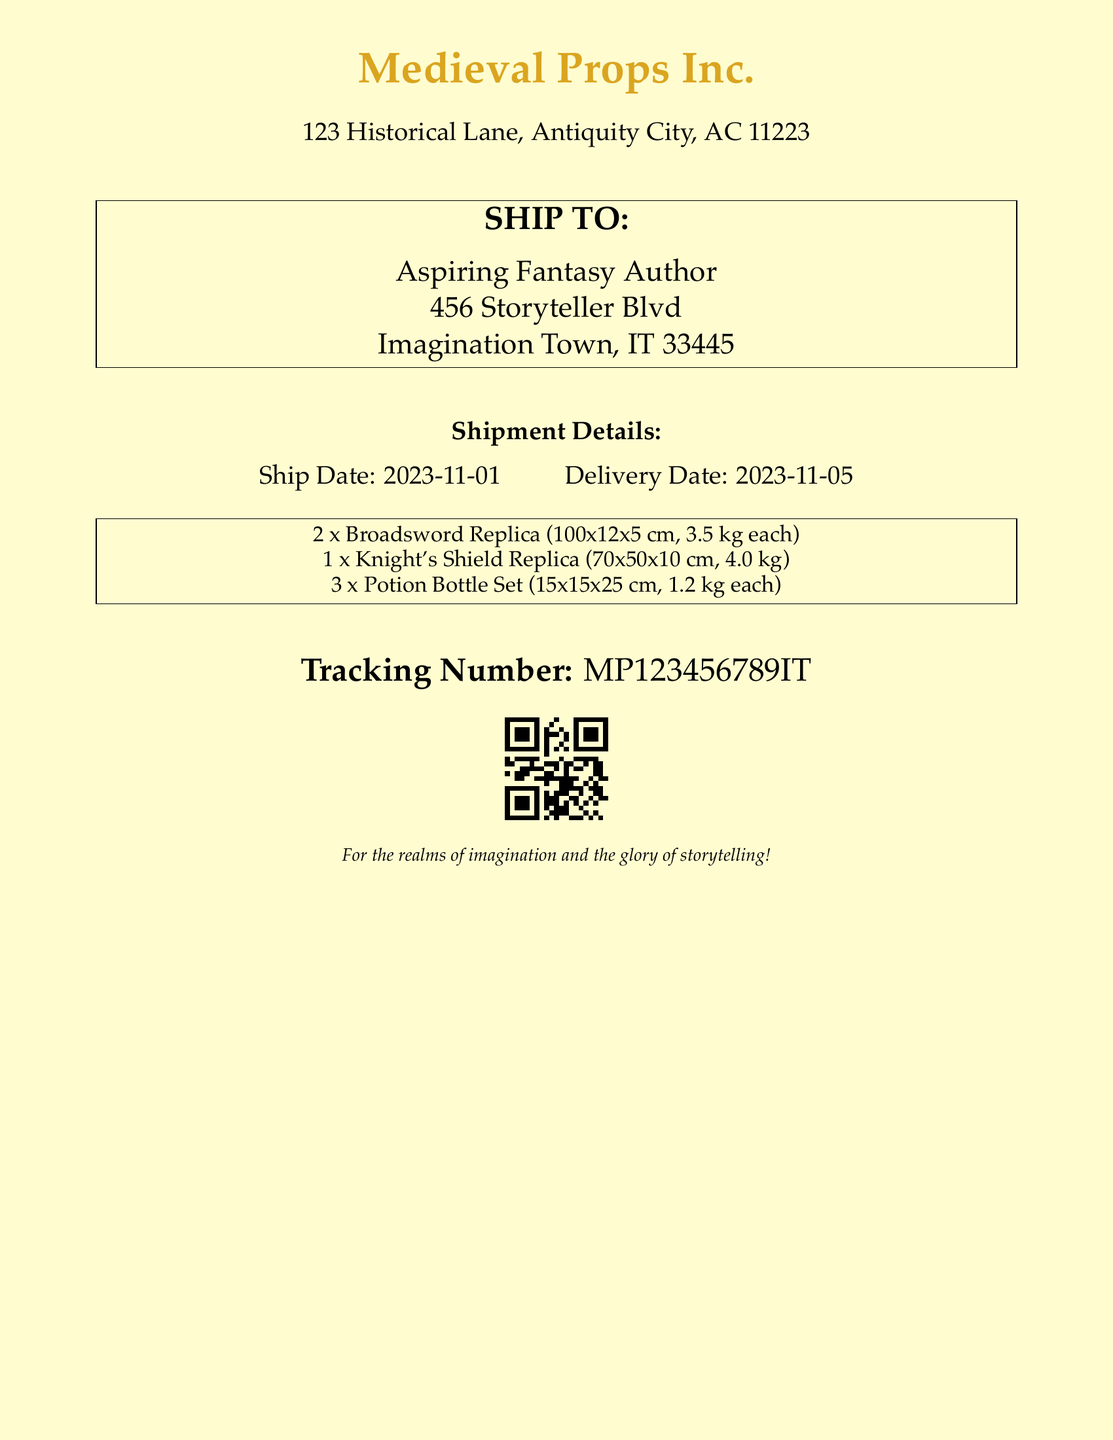What is the ship date? The ship date is the date when the items are sent, which is stated in the document.
Answer: 2023-11-01 What is the delivery date? The delivery date is the expected date of arrival for the shipment, mentioned in the document.
Answer: 2023-11-05 How many Broadsword Replicas are included? The document specifies the quantity of each item type in the shipment.
Answer: 2 What is the weight of the Knight's Shield Replica? The weight of the Knight's Shield Replica is provided in the shipment details section.
Answer: 4.0 kg What are the dimensions of the Potion Bottle Set? The document provides the dimensions for the Potion Bottle Set as part of its description.
Answer: 15x15x25 cm What is the total weight of all items in the shipment? To answer this, you can sum up the weights of each item type based on the given information.
Answer: 15.4 kg What is the tracking number? The tracking number is a unique identifier provided for the shipment.
Answer: MP123456789IT Who is the recipient of the shipment? The document specifies the name and address of the recipient in the shipping label section.
Answer: Aspiring Fantasy Author What type of document is this? Based on the content and layout, we can determine the nature of the document.
Answer: Shipping label 